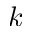Convert formula to latex. <formula><loc_0><loc_0><loc_500><loc_500>k</formula> 